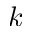Convert formula to latex. <formula><loc_0><loc_0><loc_500><loc_500>k</formula> 